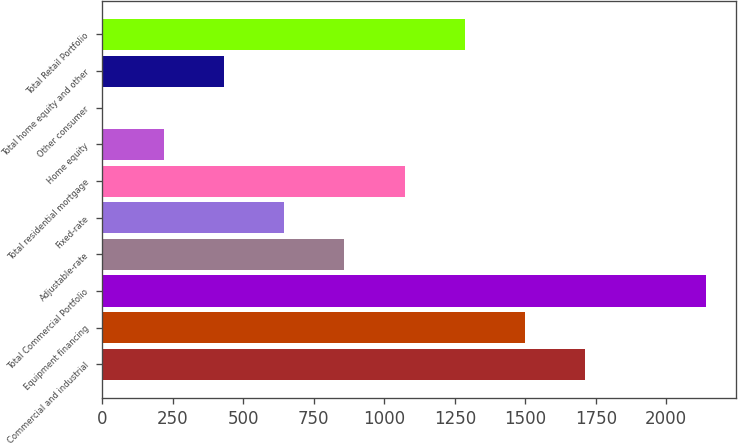Convert chart to OTSL. <chart><loc_0><loc_0><loc_500><loc_500><bar_chart><fcel>Commercial and industrial<fcel>Equipment financing<fcel>Total Commercial Portfolio<fcel>Adjustable-rate<fcel>Fixed-rate<fcel>Total residential mortgage<fcel>Home equity<fcel>Other consumer<fcel>Total home equity and other<fcel>Total Retail Portfolio<nl><fcel>1712.88<fcel>1499.22<fcel>2140.2<fcel>858.24<fcel>644.58<fcel>1071.9<fcel>217.26<fcel>3.6<fcel>430.92<fcel>1285.56<nl></chart> 